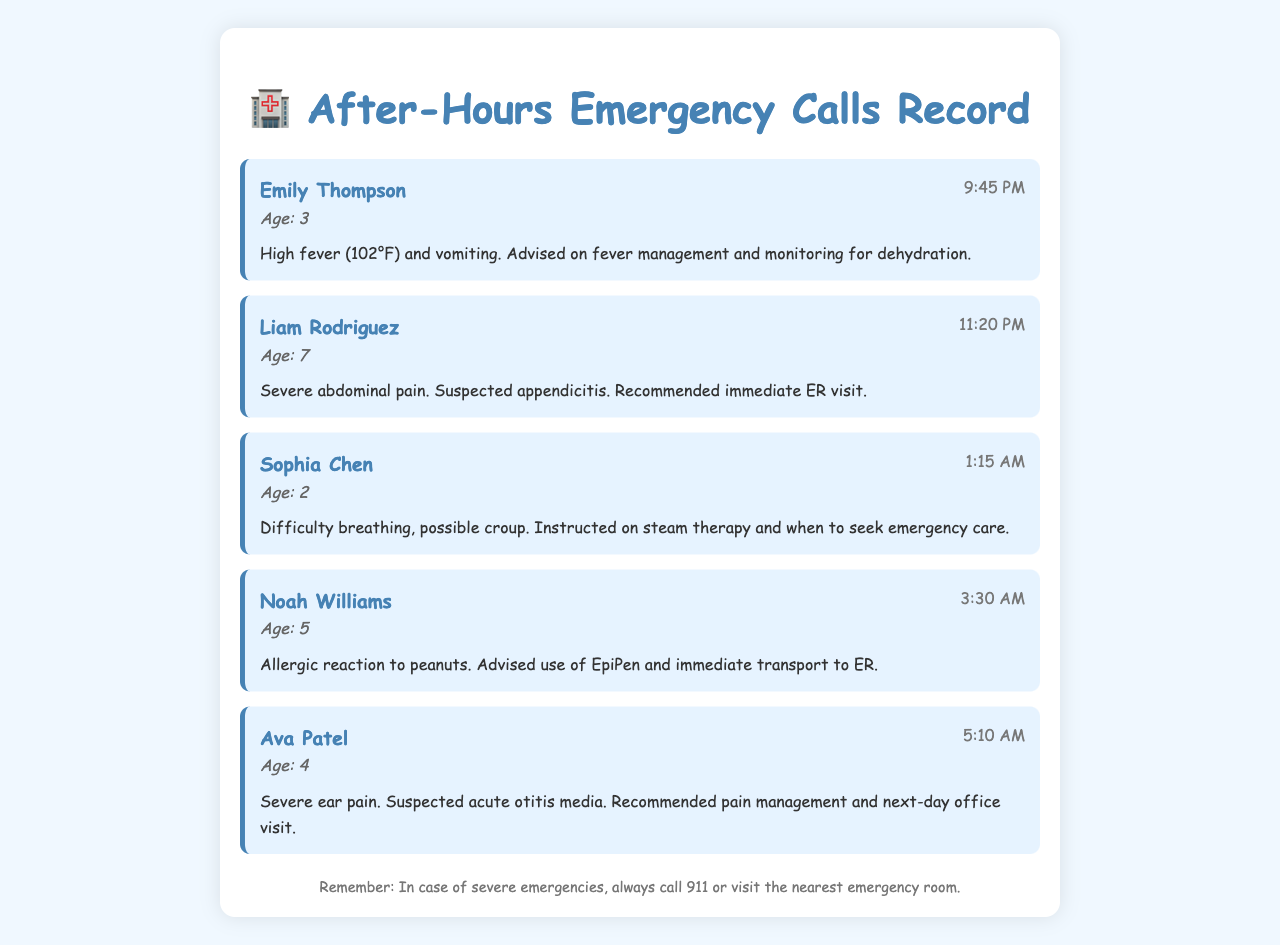What time did Emily Thompson call? The call time for Emily Thompson is clearly stated in the document as 9:45 PM.
Answer: 9:45 PM How old is Liam Rodriguez? Liam Rodriguez's age is provided in the document, which states he is 7 years old.
Answer: 7 What medical issue did Sophia Chen present? The document specifies that Sophia Chen had difficulty breathing and possible croup.
Answer: Difficulty breathing, possible croup What was the age of the patient with an allergic reaction? The document mentions that Noah Williams, who had an allergic reaction, is 5 years old.
Answer: 5 What action was recommended for Ava Patel? The document indicates that Ava Patel was recommended for pain management and a next-day office visit.
Answer: Pain management and next-day office visit Which patient had high fever? The document states that Emily Thompson experienced a high fever of 102°F.
Answer: Emily Thompson What was the suspected issue for Liam Rodriguez? The document mentions a suspected appendicitis for Liam Rodriguez's abdominal pain.
Answer: Suspected appendicitis At what time did Noah Williams call? The document notes that Noah Williams's call was received at 3:30 AM.
Answer: 3:30 AM What advice was given for Emily Thompson? The document advises on fever management and monitoring for dehydration for Emily Thompson.
Answer: Fever management and monitoring for dehydration 